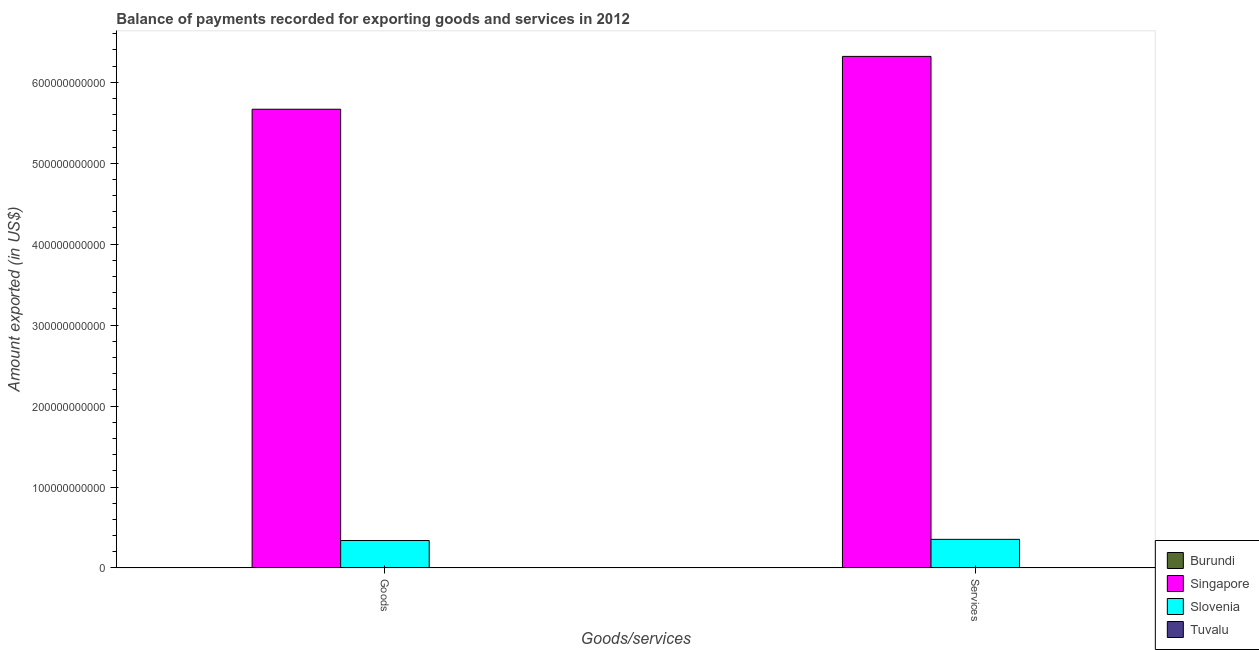How many groups of bars are there?
Provide a succinct answer. 2. Are the number of bars per tick equal to the number of legend labels?
Your answer should be compact. Yes. Are the number of bars on each tick of the X-axis equal?
Provide a succinct answer. Yes. How many bars are there on the 2nd tick from the right?
Offer a terse response. 4. What is the label of the 2nd group of bars from the left?
Offer a terse response. Services. What is the amount of goods exported in Singapore?
Offer a terse response. 5.67e+11. Across all countries, what is the maximum amount of goods exported?
Your answer should be very brief. 5.67e+11. Across all countries, what is the minimum amount of services exported?
Ensure brevity in your answer.  3.93e+07. In which country was the amount of services exported maximum?
Give a very brief answer. Singapore. In which country was the amount of services exported minimum?
Offer a terse response. Tuvalu. What is the total amount of services exported in the graph?
Give a very brief answer. 6.68e+11. What is the difference between the amount of goods exported in Burundi and that in Tuvalu?
Provide a short and direct response. 2.02e+08. What is the difference between the amount of services exported in Singapore and the amount of goods exported in Burundi?
Offer a terse response. 6.32e+11. What is the average amount of goods exported per country?
Provide a short and direct response. 1.50e+11. What is the difference between the amount of services exported and amount of goods exported in Singapore?
Your answer should be compact. 6.53e+1. In how many countries, is the amount of services exported greater than 100000000000 US$?
Your answer should be very brief. 1. What is the ratio of the amount of services exported in Slovenia to that in Singapore?
Offer a terse response. 0.06. Is the amount of services exported in Singapore less than that in Burundi?
Your answer should be compact. No. In how many countries, is the amount of goods exported greater than the average amount of goods exported taken over all countries?
Ensure brevity in your answer.  1. What does the 1st bar from the left in Services represents?
Offer a terse response. Burundi. What does the 3rd bar from the right in Services represents?
Provide a succinct answer. Singapore. How many bars are there?
Offer a very short reply. 8. What is the difference between two consecutive major ticks on the Y-axis?
Give a very brief answer. 1.00e+11. Does the graph contain any zero values?
Give a very brief answer. No. Where does the legend appear in the graph?
Offer a very short reply. Bottom right. How are the legend labels stacked?
Your answer should be compact. Vertical. What is the title of the graph?
Make the answer very short. Balance of payments recorded for exporting goods and services in 2012. What is the label or title of the X-axis?
Your response must be concise. Goods/services. What is the label or title of the Y-axis?
Your response must be concise. Amount exported (in US$). What is the Amount exported (in US$) of Burundi in Goods?
Make the answer very short. 2.28e+08. What is the Amount exported (in US$) in Singapore in Goods?
Your response must be concise. 5.67e+11. What is the Amount exported (in US$) in Slovenia in Goods?
Provide a succinct answer. 3.39e+1. What is the Amount exported (in US$) of Tuvalu in Goods?
Give a very brief answer. 2.51e+07. What is the Amount exported (in US$) of Burundi in Services?
Your answer should be compact. 2.39e+08. What is the Amount exported (in US$) of Singapore in Services?
Provide a short and direct response. 6.32e+11. What is the Amount exported (in US$) in Slovenia in Services?
Provide a succinct answer. 3.53e+1. What is the Amount exported (in US$) in Tuvalu in Services?
Give a very brief answer. 3.93e+07. Across all Goods/services, what is the maximum Amount exported (in US$) of Burundi?
Keep it short and to the point. 2.39e+08. Across all Goods/services, what is the maximum Amount exported (in US$) of Singapore?
Provide a succinct answer. 6.32e+11. Across all Goods/services, what is the maximum Amount exported (in US$) of Slovenia?
Your answer should be very brief. 3.53e+1. Across all Goods/services, what is the maximum Amount exported (in US$) in Tuvalu?
Offer a terse response. 3.93e+07. Across all Goods/services, what is the minimum Amount exported (in US$) in Burundi?
Keep it short and to the point. 2.28e+08. Across all Goods/services, what is the minimum Amount exported (in US$) of Singapore?
Provide a succinct answer. 5.67e+11. Across all Goods/services, what is the minimum Amount exported (in US$) of Slovenia?
Ensure brevity in your answer.  3.39e+1. Across all Goods/services, what is the minimum Amount exported (in US$) of Tuvalu?
Provide a succinct answer. 2.51e+07. What is the total Amount exported (in US$) in Burundi in the graph?
Offer a very short reply. 4.66e+08. What is the total Amount exported (in US$) of Singapore in the graph?
Keep it short and to the point. 1.20e+12. What is the total Amount exported (in US$) of Slovenia in the graph?
Provide a short and direct response. 6.92e+1. What is the total Amount exported (in US$) in Tuvalu in the graph?
Your answer should be very brief. 6.44e+07. What is the difference between the Amount exported (in US$) in Burundi in Goods and that in Services?
Provide a succinct answer. -1.14e+07. What is the difference between the Amount exported (in US$) in Singapore in Goods and that in Services?
Provide a succinct answer. -6.53e+1. What is the difference between the Amount exported (in US$) of Slovenia in Goods and that in Services?
Give a very brief answer. -1.46e+09. What is the difference between the Amount exported (in US$) in Tuvalu in Goods and that in Services?
Offer a very short reply. -1.42e+07. What is the difference between the Amount exported (in US$) of Burundi in Goods and the Amount exported (in US$) of Singapore in Services?
Make the answer very short. -6.32e+11. What is the difference between the Amount exported (in US$) in Burundi in Goods and the Amount exported (in US$) in Slovenia in Services?
Offer a very short reply. -3.51e+1. What is the difference between the Amount exported (in US$) in Burundi in Goods and the Amount exported (in US$) in Tuvalu in Services?
Give a very brief answer. 1.88e+08. What is the difference between the Amount exported (in US$) of Singapore in Goods and the Amount exported (in US$) of Slovenia in Services?
Give a very brief answer. 5.31e+11. What is the difference between the Amount exported (in US$) in Singapore in Goods and the Amount exported (in US$) in Tuvalu in Services?
Offer a very short reply. 5.67e+11. What is the difference between the Amount exported (in US$) in Slovenia in Goods and the Amount exported (in US$) in Tuvalu in Services?
Offer a very short reply. 3.38e+1. What is the average Amount exported (in US$) of Burundi per Goods/services?
Provide a succinct answer. 2.33e+08. What is the average Amount exported (in US$) of Singapore per Goods/services?
Offer a very short reply. 5.99e+11. What is the average Amount exported (in US$) in Slovenia per Goods/services?
Give a very brief answer. 3.46e+1. What is the average Amount exported (in US$) of Tuvalu per Goods/services?
Offer a very short reply. 3.22e+07. What is the difference between the Amount exported (in US$) in Burundi and Amount exported (in US$) in Singapore in Goods?
Provide a short and direct response. -5.66e+11. What is the difference between the Amount exported (in US$) of Burundi and Amount exported (in US$) of Slovenia in Goods?
Your answer should be compact. -3.36e+1. What is the difference between the Amount exported (in US$) in Burundi and Amount exported (in US$) in Tuvalu in Goods?
Ensure brevity in your answer.  2.02e+08. What is the difference between the Amount exported (in US$) in Singapore and Amount exported (in US$) in Slovenia in Goods?
Your answer should be very brief. 5.33e+11. What is the difference between the Amount exported (in US$) in Singapore and Amount exported (in US$) in Tuvalu in Goods?
Your answer should be very brief. 5.67e+11. What is the difference between the Amount exported (in US$) in Slovenia and Amount exported (in US$) in Tuvalu in Goods?
Your answer should be compact. 3.39e+1. What is the difference between the Amount exported (in US$) in Burundi and Amount exported (in US$) in Singapore in Services?
Give a very brief answer. -6.32e+11. What is the difference between the Amount exported (in US$) of Burundi and Amount exported (in US$) of Slovenia in Services?
Your answer should be very brief. -3.51e+1. What is the difference between the Amount exported (in US$) in Burundi and Amount exported (in US$) in Tuvalu in Services?
Provide a succinct answer. 2.00e+08. What is the difference between the Amount exported (in US$) of Singapore and Amount exported (in US$) of Slovenia in Services?
Provide a succinct answer. 5.97e+11. What is the difference between the Amount exported (in US$) of Singapore and Amount exported (in US$) of Tuvalu in Services?
Provide a succinct answer. 6.32e+11. What is the difference between the Amount exported (in US$) in Slovenia and Amount exported (in US$) in Tuvalu in Services?
Offer a terse response. 3.53e+1. What is the ratio of the Amount exported (in US$) in Burundi in Goods to that in Services?
Offer a terse response. 0.95. What is the ratio of the Amount exported (in US$) in Singapore in Goods to that in Services?
Your response must be concise. 0.9. What is the ratio of the Amount exported (in US$) in Slovenia in Goods to that in Services?
Keep it short and to the point. 0.96. What is the ratio of the Amount exported (in US$) of Tuvalu in Goods to that in Services?
Keep it short and to the point. 0.64. What is the difference between the highest and the second highest Amount exported (in US$) in Burundi?
Make the answer very short. 1.14e+07. What is the difference between the highest and the second highest Amount exported (in US$) of Singapore?
Provide a short and direct response. 6.53e+1. What is the difference between the highest and the second highest Amount exported (in US$) of Slovenia?
Give a very brief answer. 1.46e+09. What is the difference between the highest and the second highest Amount exported (in US$) in Tuvalu?
Your response must be concise. 1.42e+07. What is the difference between the highest and the lowest Amount exported (in US$) of Burundi?
Keep it short and to the point. 1.14e+07. What is the difference between the highest and the lowest Amount exported (in US$) in Singapore?
Provide a short and direct response. 6.53e+1. What is the difference between the highest and the lowest Amount exported (in US$) of Slovenia?
Keep it short and to the point. 1.46e+09. What is the difference between the highest and the lowest Amount exported (in US$) of Tuvalu?
Ensure brevity in your answer.  1.42e+07. 